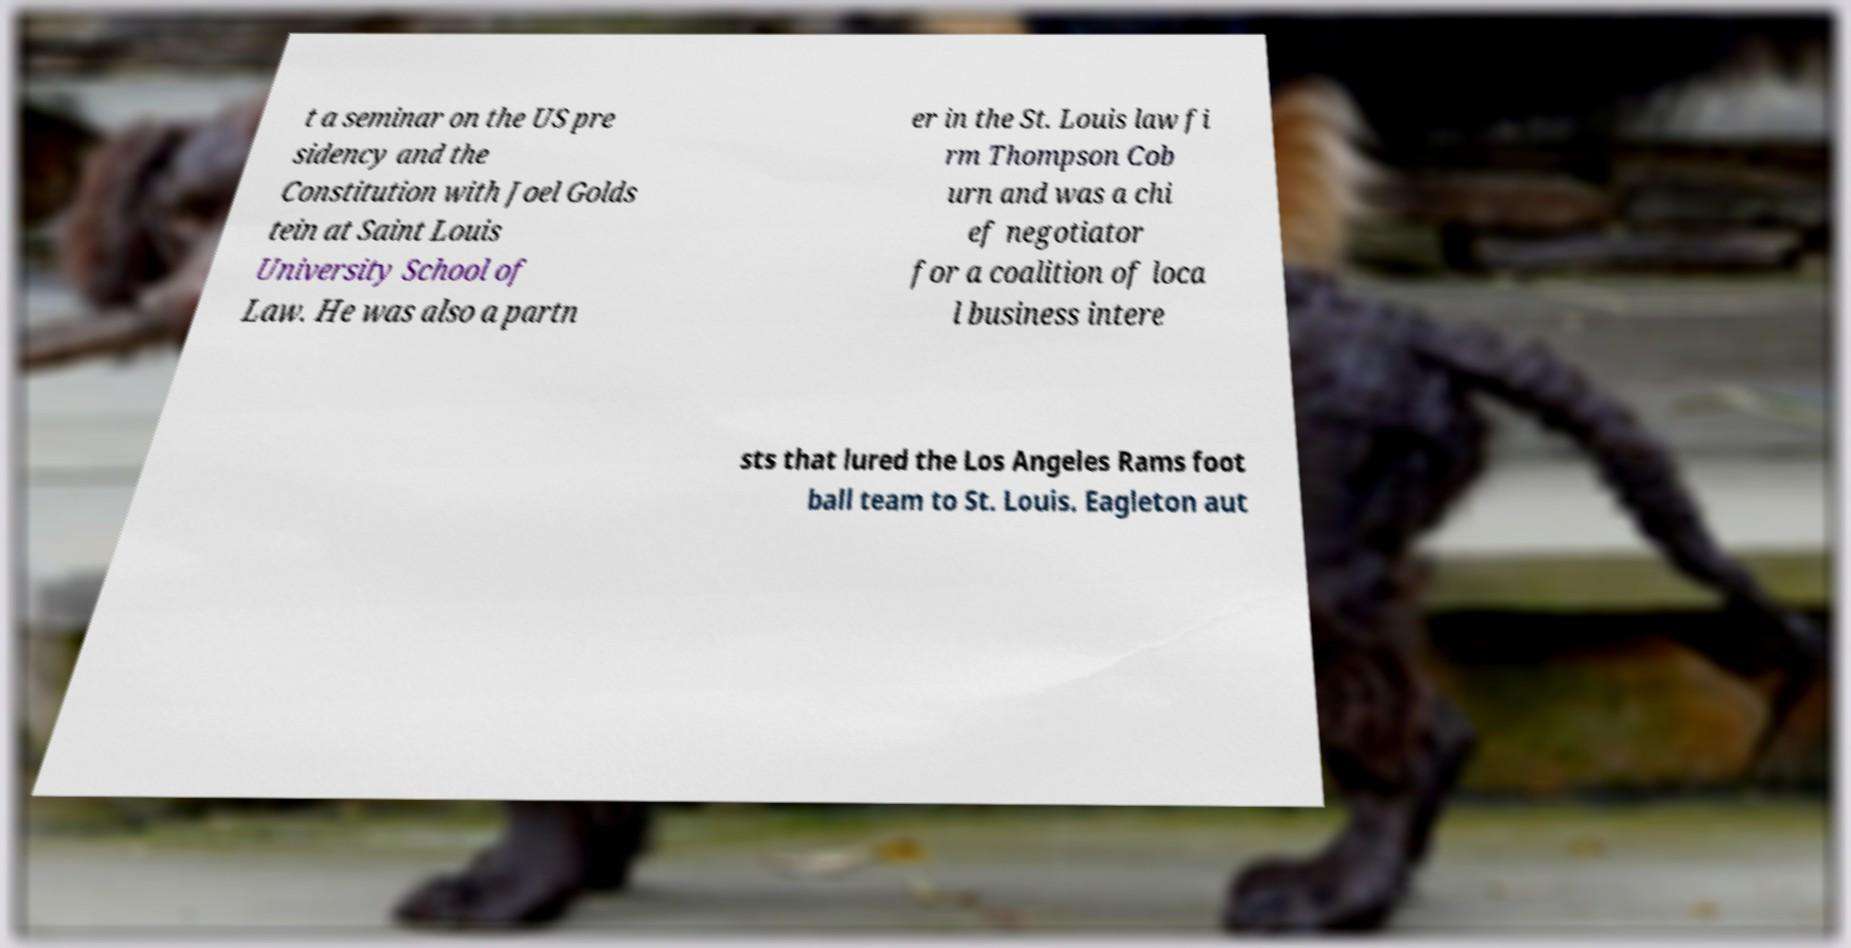Please read and relay the text visible in this image. What does it say? t a seminar on the US pre sidency and the Constitution with Joel Golds tein at Saint Louis University School of Law. He was also a partn er in the St. Louis law fi rm Thompson Cob urn and was a chi ef negotiator for a coalition of loca l business intere sts that lured the Los Angeles Rams foot ball team to St. Louis. Eagleton aut 